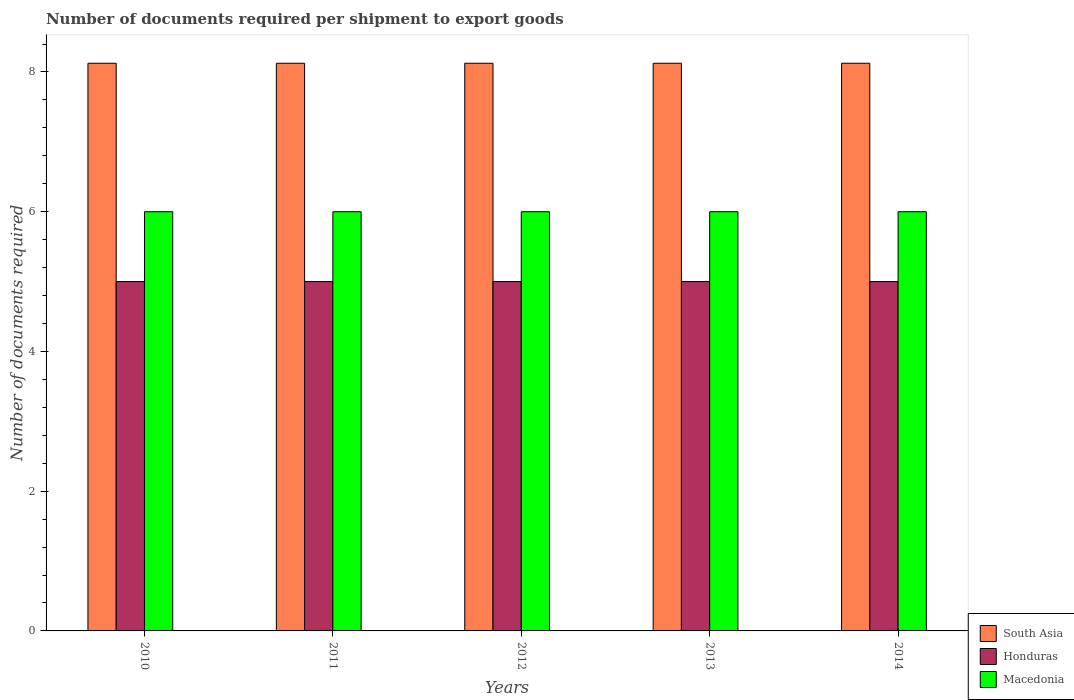Are the number of bars per tick equal to the number of legend labels?
Offer a very short reply. Yes. How many bars are there on the 2nd tick from the left?
Keep it short and to the point. 3. How many bars are there on the 4th tick from the right?
Make the answer very short. 3. What is the label of the 5th group of bars from the left?
Give a very brief answer. 2014. What is the number of documents required per shipment to export goods in South Asia in 2010?
Your answer should be very brief. 8.12. Across all years, what is the maximum number of documents required per shipment to export goods in Honduras?
Make the answer very short. 5. Across all years, what is the minimum number of documents required per shipment to export goods in South Asia?
Your response must be concise. 8.12. In which year was the number of documents required per shipment to export goods in Honduras minimum?
Give a very brief answer. 2010. What is the total number of documents required per shipment to export goods in South Asia in the graph?
Your answer should be very brief. 40.62. What is the difference between the number of documents required per shipment to export goods in South Asia in 2010 and that in 2013?
Your answer should be very brief. 0. What is the difference between the number of documents required per shipment to export goods in Honduras in 2011 and the number of documents required per shipment to export goods in Macedonia in 2013?
Provide a succinct answer. -1. What is the average number of documents required per shipment to export goods in South Asia per year?
Provide a short and direct response. 8.12. In the year 2011, what is the difference between the number of documents required per shipment to export goods in Honduras and number of documents required per shipment to export goods in South Asia?
Give a very brief answer. -3.12. In how many years, is the number of documents required per shipment to export goods in South Asia greater than 5.2?
Your answer should be compact. 5. What is the ratio of the number of documents required per shipment to export goods in South Asia in 2013 to that in 2014?
Your answer should be compact. 1. In how many years, is the number of documents required per shipment to export goods in Macedonia greater than the average number of documents required per shipment to export goods in Macedonia taken over all years?
Provide a short and direct response. 0. What does the 1st bar from the left in 2012 represents?
Give a very brief answer. South Asia. What does the 2nd bar from the right in 2011 represents?
Provide a short and direct response. Honduras. Is it the case that in every year, the sum of the number of documents required per shipment to export goods in Macedonia and number of documents required per shipment to export goods in South Asia is greater than the number of documents required per shipment to export goods in Honduras?
Ensure brevity in your answer.  Yes. How many bars are there?
Provide a succinct answer. 15. How many years are there in the graph?
Your answer should be compact. 5. What is the difference between two consecutive major ticks on the Y-axis?
Provide a succinct answer. 2. Are the values on the major ticks of Y-axis written in scientific E-notation?
Your answer should be very brief. No. Where does the legend appear in the graph?
Make the answer very short. Bottom right. How many legend labels are there?
Your answer should be very brief. 3. How are the legend labels stacked?
Provide a succinct answer. Vertical. What is the title of the graph?
Your answer should be compact. Number of documents required per shipment to export goods. What is the label or title of the Y-axis?
Your answer should be compact. Number of documents required. What is the Number of documents required of South Asia in 2010?
Provide a short and direct response. 8.12. What is the Number of documents required in Macedonia in 2010?
Offer a terse response. 6. What is the Number of documents required in South Asia in 2011?
Provide a short and direct response. 8.12. What is the Number of documents required of Macedonia in 2011?
Provide a short and direct response. 6. What is the Number of documents required of South Asia in 2012?
Give a very brief answer. 8.12. What is the Number of documents required of South Asia in 2013?
Your answer should be very brief. 8.12. What is the Number of documents required in South Asia in 2014?
Keep it short and to the point. 8.12. Across all years, what is the maximum Number of documents required in South Asia?
Offer a terse response. 8.12. Across all years, what is the maximum Number of documents required of Honduras?
Your answer should be compact. 5. Across all years, what is the maximum Number of documents required of Macedonia?
Your answer should be very brief. 6. Across all years, what is the minimum Number of documents required of South Asia?
Your answer should be compact. 8.12. Across all years, what is the minimum Number of documents required of Honduras?
Provide a succinct answer. 5. What is the total Number of documents required in South Asia in the graph?
Provide a short and direct response. 40.62. What is the total Number of documents required of Honduras in the graph?
Your response must be concise. 25. What is the total Number of documents required in Macedonia in the graph?
Offer a terse response. 30. What is the difference between the Number of documents required of South Asia in 2010 and that in 2011?
Offer a very short reply. 0. What is the difference between the Number of documents required in Honduras in 2010 and that in 2011?
Provide a succinct answer. 0. What is the difference between the Number of documents required in South Asia in 2010 and that in 2013?
Make the answer very short. 0. What is the difference between the Number of documents required of Macedonia in 2010 and that in 2013?
Give a very brief answer. 0. What is the difference between the Number of documents required in South Asia in 2010 and that in 2014?
Offer a very short reply. 0. What is the difference between the Number of documents required of Honduras in 2010 and that in 2014?
Provide a succinct answer. 0. What is the difference between the Number of documents required of Macedonia in 2010 and that in 2014?
Provide a succinct answer. 0. What is the difference between the Number of documents required in South Asia in 2011 and that in 2012?
Your answer should be very brief. 0. What is the difference between the Number of documents required in Honduras in 2011 and that in 2013?
Your answer should be compact. 0. What is the difference between the Number of documents required of Macedonia in 2011 and that in 2014?
Your answer should be compact. 0. What is the difference between the Number of documents required of Honduras in 2012 and that in 2013?
Keep it short and to the point. 0. What is the difference between the Number of documents required in Macedonia in 2012 and that in 2013?
Your response must be concise. 0. What is the difference between the Number of documents required of South Asia in 2013 and that in 2014?
Offer a terse response. 0. What is the difference between the Number of documents required in Macedonia in 2013 and that in 2014?
Your answer should be compact. 0. What is the difference between the Number of documents required of South Asia in 2010 and the Number of documents required of Honduras in 2011?
Your answer should be very brief. 3.12. What is the difference between the Number of documents required in South Asia in 2010 and the Number of documents required in Macedonia in 2011?
Your answer should be compact. 2.12. What is the difference between the Number of documents required of Honduras in 2010 and the Number of documents required of Macedonia in 2011?
Provide a short and direct response. -1. What is the difference between the Number of documents required of South Asia in 2010 and the Number of documents required of Honduras in 2012?
Ensure brevity in your answer.  3.12. What is the difference between the Number of documents required in South Asia in 2010 and the Number of documents required in Macedonia in 2012?
Keep it short and to the point. 2.12. What is the difference between the Number of documents required in Honduras in 2010 and the Number of documents required in Macedonia in 2012?
Provide a succinct answer. -1. What is the difference between the Number of documents required of South Asia in 2010 and the Number of documents required of Honduras in 2013?
Ensure brevity in your answer.  3.12. What is the difference between the Number of documents required of South Asia in 2010 and the Number of documents required of Macedonia in 2013?
Provide a short and direct response. 2.12. What is the difference between the Number of documents required of Honduras in 2010 and the Number of documents required of Macedonia in 2013?
Provide a succinct answer. -1. What is the difference between the Number of documents required in South Asia in 2010 and the Number of documents required in Honduras in 2014?
Offer a terse response. 3.12. What is the difference between the Number of documents required in South Asia in 2010 and the Number of documents required in Macedonia in 2014?
Offer a terse response. 2.12. What is the difference between the Number of documents required of Honduras in 2010 and the Number of documents required of Macedonia in 2014?
Provide a succinct answer. -1. What is the difference between the Number of documents required in South Asia in 2011 and the Number of documents required in Honduras in 2012?
Your answer should be compact. 3.12. What is the difference between the Number of documents required in South Asia in 2011 and the Number of documents required in Macedonia in 2012?
Ensure brevity in your answer.  2.12. What is the difference between the Number of documents required in South Asia in 2011 and the Number of documents required in Honduras in 2013?
Keep it short and to the point. 3.12. What is the difference between the Number of documents required in South Asia in 2011 and the Number of documents required in Macedonia in 2013?
Your answer should be compact. 2.12. What is the difference between the Number of documents required of Honduras in 2011 and the Number of documents required of Macedonia in 2013?
Make the answer very short. -1. What is the difference between the Number of documents required of South Asia in 2011 and the Number of documents required of Honduras in 2014?
Provide a short and direct response. 3.12. What is the difference between the Number of documents required of South Asia in 2011 and the Number of documents required of Macedonia in 2014?
Ensure brevity in your answer.  2.12. What is the difference between the Number of documents required in Honduras in 2011 and the Number of documents required in Macedonia in 2014?
Provide a short and direct response. -1. What is the difference between the Number of documents required of South Asia in 2012 and the Number of documents required of Honduras in 2013?
Give a very brief answer. 3.12. What is the difference between the Number of documents required of South Asia in 2012 and the Number of documents required of Macedonia in 2013?
Give a very brief answer. 2.12. What is the difference between the Number of documents required of South Asia in 2012 and the Number of documents required of Honduras in 2014?
Ensure brevity in your answer.  3.12. What is the difference between the Number of documents required of South Asia in 2012 and the Number of documents required of Macedonia in 2014?
Keep it short and to the point. 2.12. What is the difference between the Number of documents required in Honduras in 2012 and the Number of documents required in Macedonia in 2014?
Give a very brief answer. -1. What is the difference between the Number of documents required in South Asia in 2013 and the Number of documents required in Honduras in 2014?
Make the answer very short. 3.12. What is the difference between the Number of documents required of South Asia in 2013 and the Number of documents required of Macedonia in 2014?
Your response must be concise. 2.12. What is the difference between the Number of documents required of Honduras in 2013 and the Number of documents required of Macedonia in 2014?
Offer a very short reply. -1. What is the average Number of documents required of South Asia per year?
Offer a terse response. 8.12. What is the average Number of documents required in Honduras per year?
Give a very brief answer. 5. What is the average Number of documents required of Macedonia per year?
Provide a short and direct response. 6. In the year 2010, what is the difference between the Number of documents required of South Asia and Number of documents required of Honduras?
Give a very brief answer. 3.12. In the year 2010, what is the difference between the Number of documents required of South Asia and Number of documents required of Macedonia?
Keep it short and to the point. 2.12. In the year 2011, what is the difference between the Number of documents required in South Asia and Number of documents required in Honduras?
Offer a terse response. 3.12. In the year 2011, what is the difference between the Number of documents required in South Asia and Number of documents required in Macedonia?
Make the answer very short. 2.12. In the year 2011, what is the difference between the Number of documents required of Honduras and Number of documents required of Macedonia?
Make the answer very short. -1. In the year 2012, what is the difference between the Number of documents required in South Asia and Number of documents required in Honduras?
Offer a very short reply. 3.12. In the year 2012, what is the difference between the Number of documents required of South Asia and Number of documents required of Macedonia?
Your response must be concise. 2.12. In the year 2012, what is the difference between the Number of documents required of Honduras and Number of documents required of Macedonia?
Your answer should be very brief. -1. In the year 2013, what is the difference between the Number of documents required of South Asia and Number of documents required of Honduras?
Ensure brevity in your answer.  3.12. In the year 2013, what is the difference between the Number of documents required of South Asia and Number of documents required of Macedonia?
Your answer should be compact. 2.12. In the year 2013, what is the difference between the Number of documents required in Honduras and Number of documents required in Macedonia?
Keep it short and to the point. -1. In the year 2014, what is the difference between the Number of documents required in South Asia and Number of documents required in Honduras?
Your answer should be very brief. 3.12. In the year 2014, what is the difference between the Number of documents required in South Asia and Number of documents required in Macedonia?
Ensure brevity in your answer.  2.12. What is the ratio of the Number of documents required of South Asia in 2010 to that in 2012?
Provide a short and direct response. 1. What is the ratio of the Number of documents required of South Asia in 2010 to that in 2013?
Offer a terse response. 1. What is the ratio of the Number of documents required of Honduras in 2010 to that in 2014?
Make the answer very short. 1. What is the ratio of the Number of documents required in Honduras in 2011 to that in 2012?
Offer a very short reply. 1. What is the ratio of the Number of documents required in South Asia in 2011 to that in 2013?
Offer a very short reply. 1. What is the ratio of the Number of documents required of Honduras in 2011 to that in 2013?
Provide a short and direct response. 1. What is the ratio of the Number of documents required of Honduras in 2012 to that in 2013?
Your answer should be compact. 1. What is the ratio of the Number of documents required of South Asia in 2012 to that in 2014?
Offer a terse response. 1. What is the ratio of the Number of documents required in Macedonia in 2012 to that in 2014?
Provide a succinct answer. 1. What is the ratio of the Number of documents required of South Asia in 2013 to that in 2014?
Your response must be concise. 1. What is the ratio of the Number of documents required in Honduras in 2013 to that in 2014?
Provide a short and direct response. 1. What is the ratio of the Number of documents required of Macedonia in 2013 to that in 2014?
Your response must be concise. 1. What is the difference between the highest and the second highest Number of documents required in South Asia?
Your response must be concise. 0. What is the difference between the highest and the lowest Number of documents required of South Asia?
Give a very brief answer. 0. 